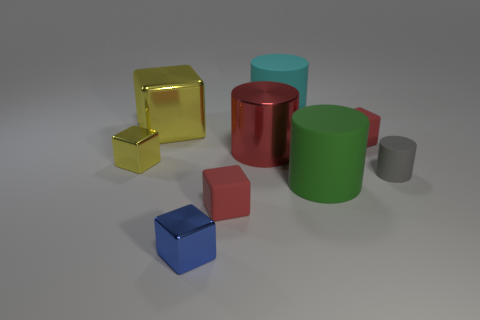Add 1 purple matte cylinders. How many objects exist? 10 Subtract all tiny red cubes. How many cubes are left? 3 Subtract all cylinders. How many objects are left? 5 Subtract 3 cubes. How many cubes are left? 2 Subtract all red blocks. How many blocks are left? 3 Subtract 0 brown cubes. How many objects are left? 9 Subtract all brown cylinders. Subtract all gray spheres. How many cylinders are left? 4 Subtract all gray cylinders. How many red cubes are left? 2 Subtract all small rubber spheres. Subtract all big green objects. How many objects are left? 8 Add 3 large cubes. How many large cubes are left? 4 